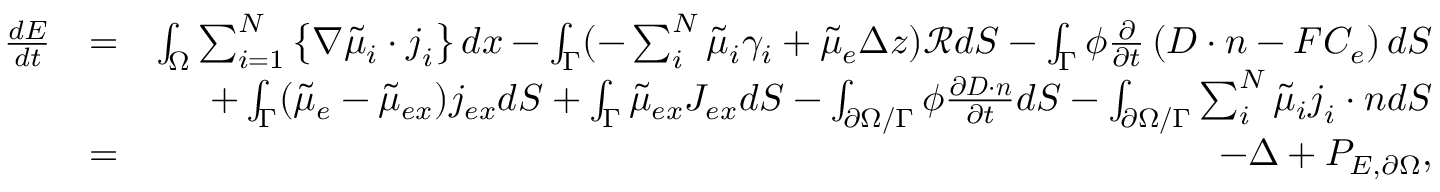Convert formula to latex. <formula><loc_0><loc_0><loc_500><loc_500>\begin{array} { r l r } { \frac { d E } { d t } } & { = } & { \int _ { \Omega } \sum _ { i = 1 } ^ { N } \left \{ \nabla \tilde { \mu } _ { i } \cdot j _ { i } \right \} d x - \int _ { \Gamma } ( - \sum _ { i } ^ { N } \tilde { \mu } _ { i } \gamma _ { i } + \tilde { \mu } _ { e } \Delta z ) \mathcal { R } d S - \int _ { \Gamma } \phi \frac { \partial } { \partial t } \left ( D \cdot n - F C _ { e } \right ) d S } \\ & { + \int _ { \Gamma } ( \tilde { \mu } _ { e } - \tilde { \mu } _ { e x } ) j _ { e x } d S + \int _ { \Gamma } \tilde { \mu } _ { e x } J _ { e x } d S - \int _ { \partial \Omega / \Gamma } \phi \frac { \partial D \cdot n } { \partial t } d S - \int _ { \partial \Omega / \Gamma } \sum _ { i } ^ { N } \tilde { \mu } _ { i } j _ { i } \cdot n d S } \\ & { = } & { - \Delta + P _ { E , \partial \Omega } , } \end{array}</formula> 